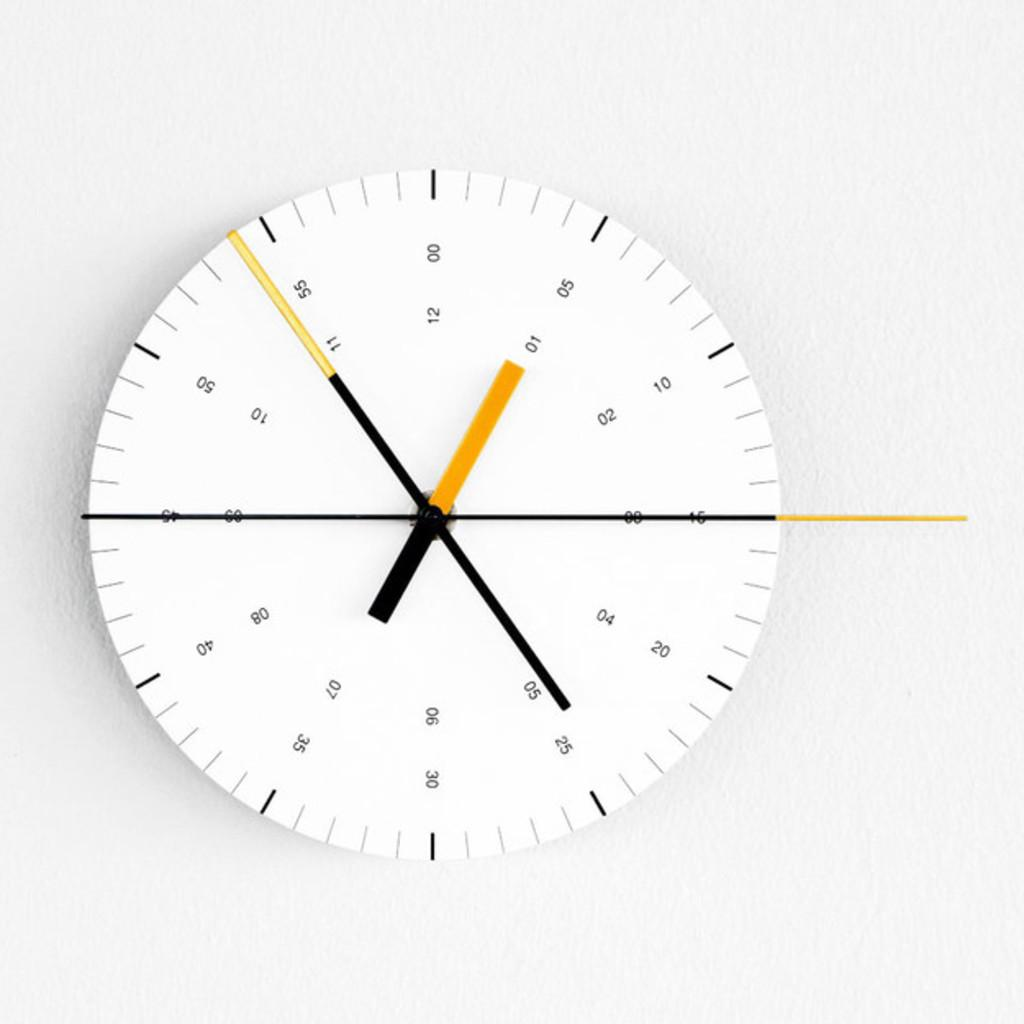<image>
Offer a succinct explanation of the picture presented. A white clock reads that it is 1:54. 